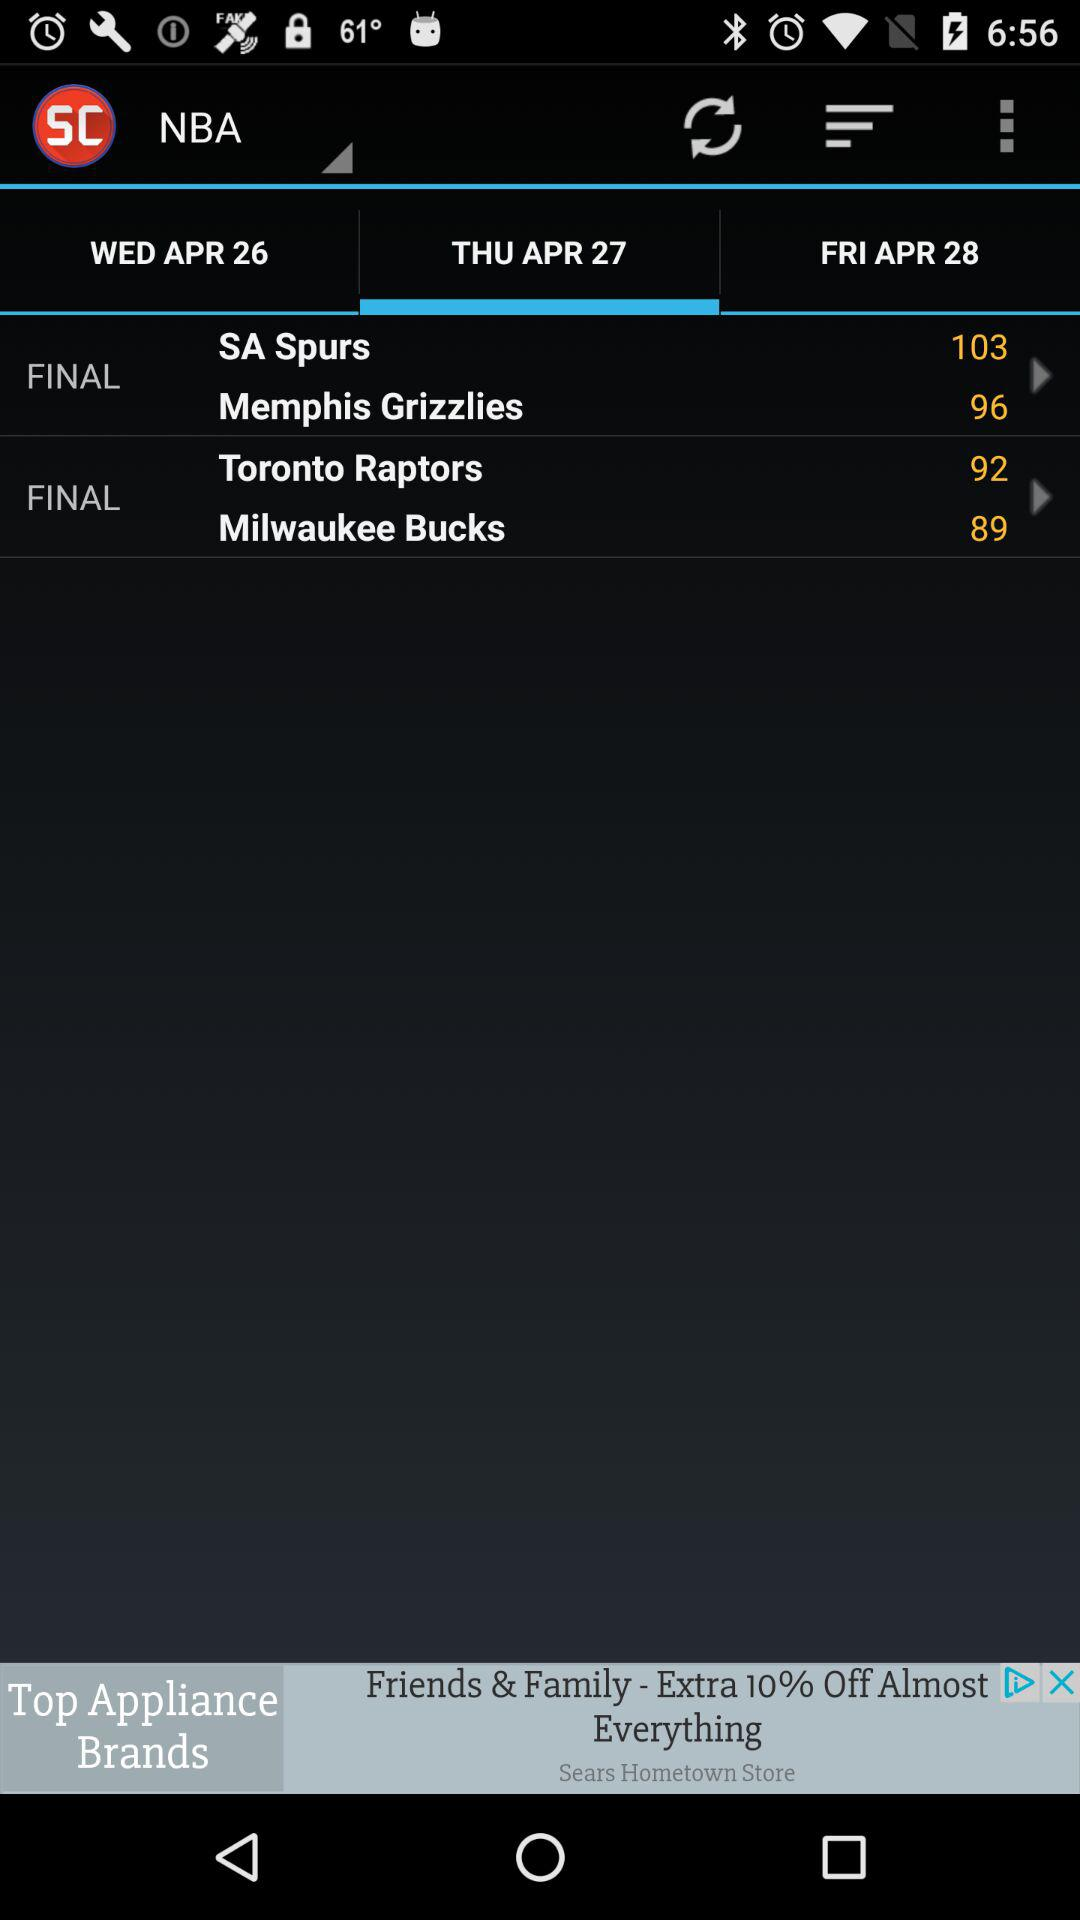Which date is selected for the finals between the "Toronto Raptors" and the "Milwaukee Bucks"? The selected date is Thursday, April 27. 